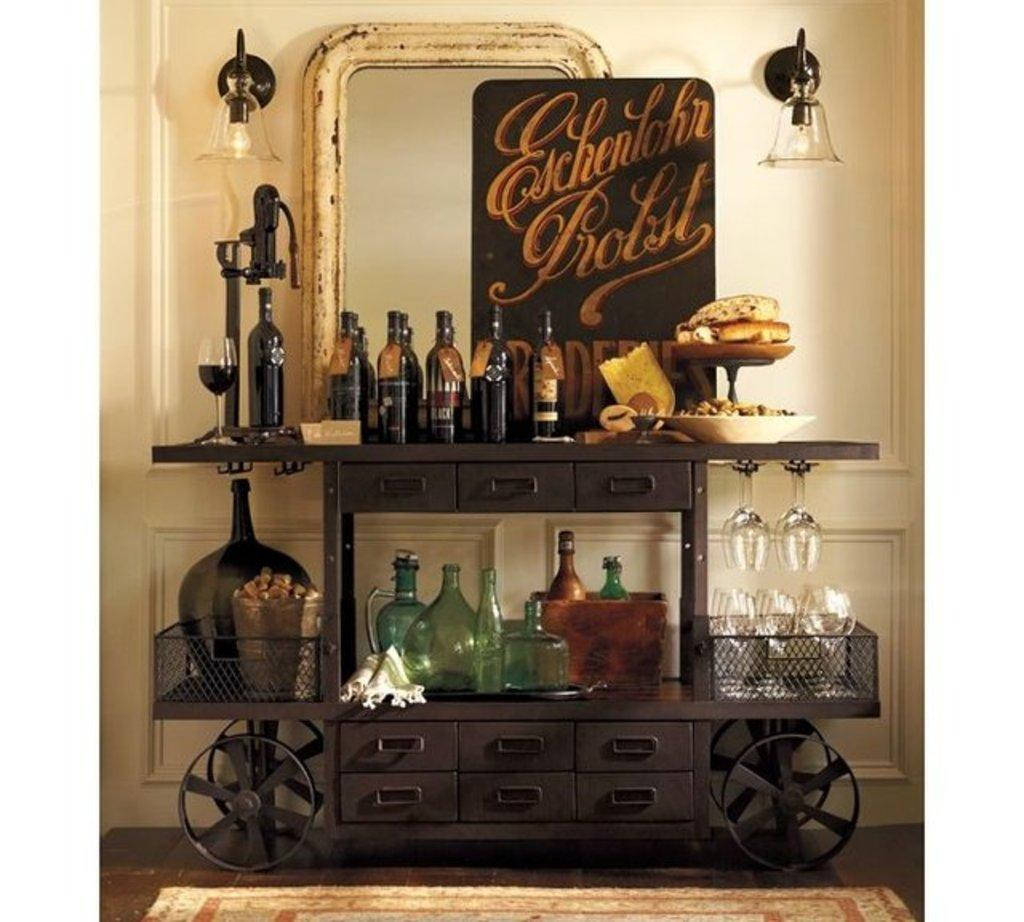<image>
Relay a brief, clear account of the picture shown. Wine table that says "Eschenbohr Profit" on it. 